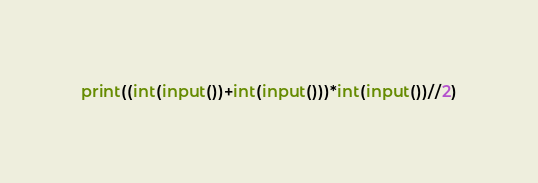Convert code to text. <code><loc_0><loc_0><loc_500><loc_500><_Python_>print((int(input())+int(input()))*int(input())//2)</code> 